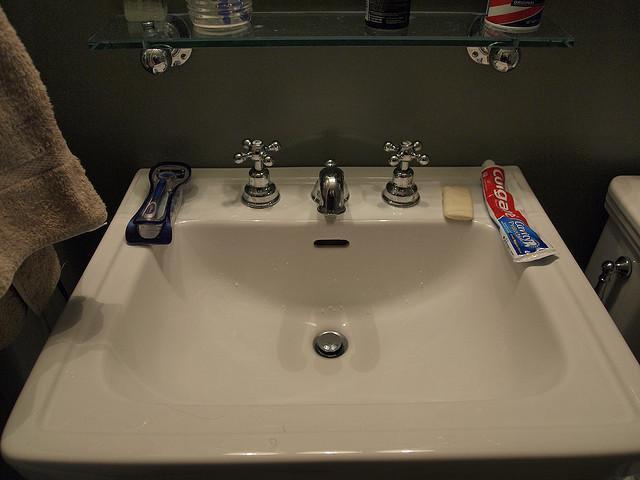What will they squeeze the substance in the tube onto?
Answer the question by selecting the correct answer among the 4 following choices.
Options: Onto washcloth, toothbrush, into sink, onto soap. Toothbrush. 